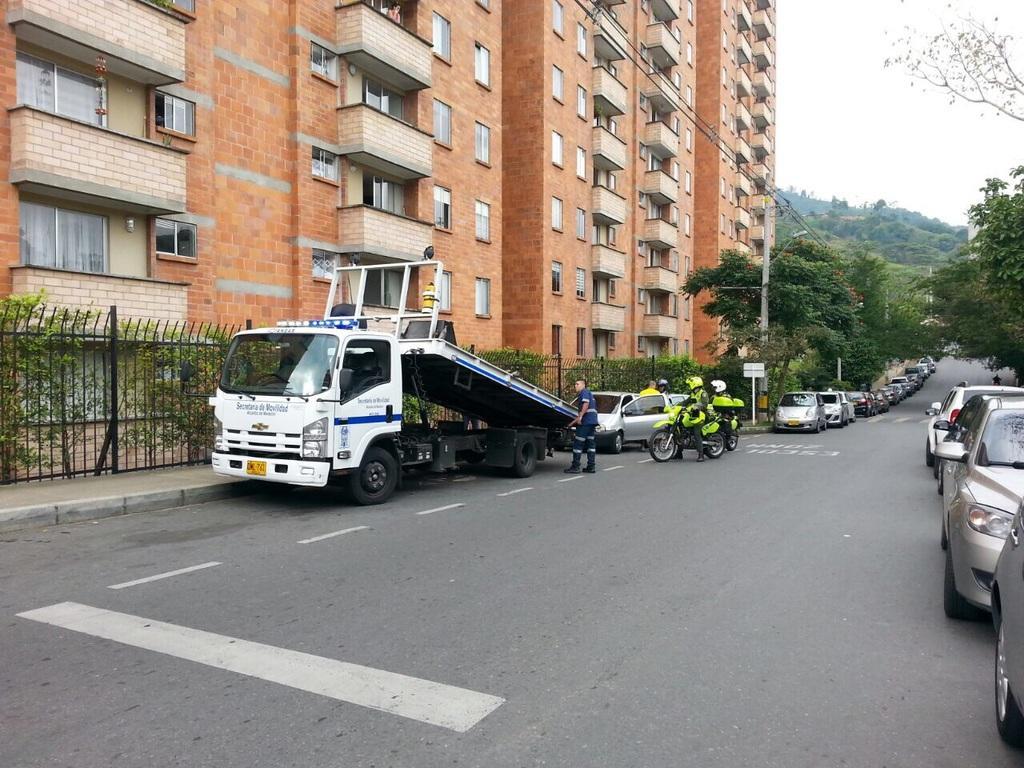Can you describe this image briefly? In the center of the image there is a road and there are vehicles on the road. To the left side of the image there are buildings. In the background of the image there are trees. There is a fencing. 